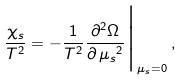<formula> <loc_0><loc_0><loc_500><loc_500>\frac { \chi _ { s } } { T ^ { 2 } } = - \frac { 1 } { T ^ { 2 } } \frac { \partial ^ { 2 } \Omega } { \partial \, { \mu _ { s } } ^ { 2 } } \Big | _ { \mu _ { s } = 0 } \, ,</formula> 